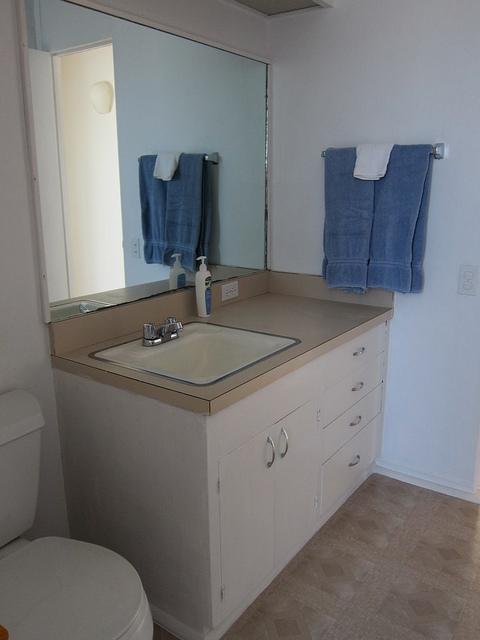Does someone eschew plain interiors?
Quick response, please. Yes. What room is this?
Answer briefly. Bathroom. What is in the bottle on the desk?
Keep it brief. Soap. What is on the counter?
Give a very brief answer. Soap. Is there a towel on the rack?
Short answer required. Yes. What color is the floor?
Give a very brief answer. Brown. Is the bathroom sink under a mirror?
Quick response, please. Yes. What shape is the sink?
Concise answer only. Square. Why painted white color?
Quick response, please. Clean. What is the black object on the counter?
Short answer required. No black object. Are there any toothbrushes on the counter?
Write a very short answer. No. Is there any color in this room?
Keep it brief. Yes. How many washcloths are pictured?
Concise answer only. 1. What room is pictured here?
Keep it brief. Bathroom. What kind of room is this?
Answer briefly. Bathroom. Do you see toothpaste?
Keep it brief. No. Would this be a good place to put a dining room table?
Keep it brief. No. Which room is this?
Give a very brief answer. Bathroom. How many sinks are there?
Keep it brief. 1. Are these walls too dark?
Give a very brief answer. No. Can you spot any towels?
Give a very brief answer. Yes. Where in the house is this room?
Give a very brief answer. Bathroom. How many sinks?
Keep it brief. 1. What color is the sink?
Be succinct. White. Is this room messy?
Answer briefly. No. Is this an antique?
Be succinct. No. Is the toilet seat open?
Write a very short answer. No. Are there any towels on the rack?
Quick response, please. Yes. Have the towels been used?
Be succinct. No. What is the floor made of?
Be succinct. Wood. Is there an oval mirror in this bathroom?
Give a very brief answer. No. What are hanging on the wall?
Quick response, please. Towels. What color is the wall?
Quick response, please. White. 